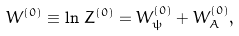Convert formula to latex. <formula><loc_0><loc_0><loc_500><loc_500>W ^ { ( 0 ) } \equiv \ln \, Z ^ { ( 0 ) } = W _ { \psi } ^ { ( 0 ) } + W _ { A } ^ { ( 0 ) } ,</formula> 